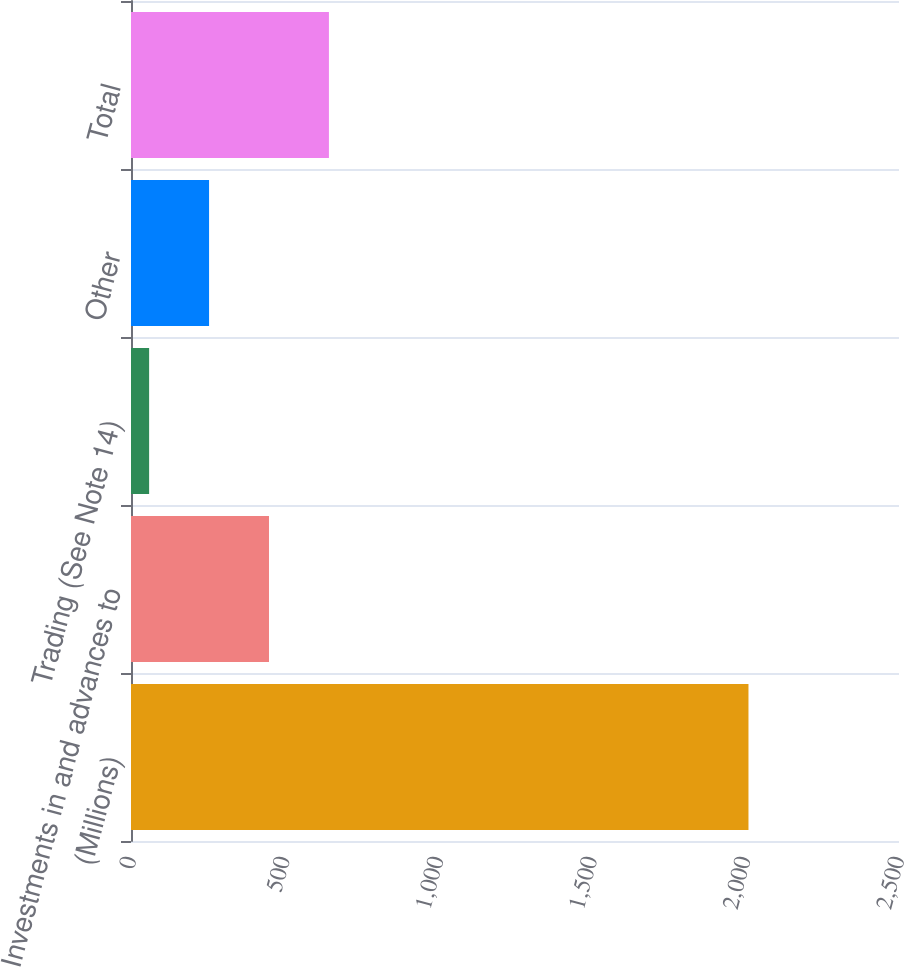<chart> <loc_0><loc_0><loc_500><loc_500><bar_chart><fcel>(Millions)<fcel>Investments in and advances to<fcel>Trading (See Note 14)<fcel>Other<fcel>Total<nl><fcel>2010<fcel>449.2<fcel>59<fcel>254.1<fcel>644.3<nl></chart> 